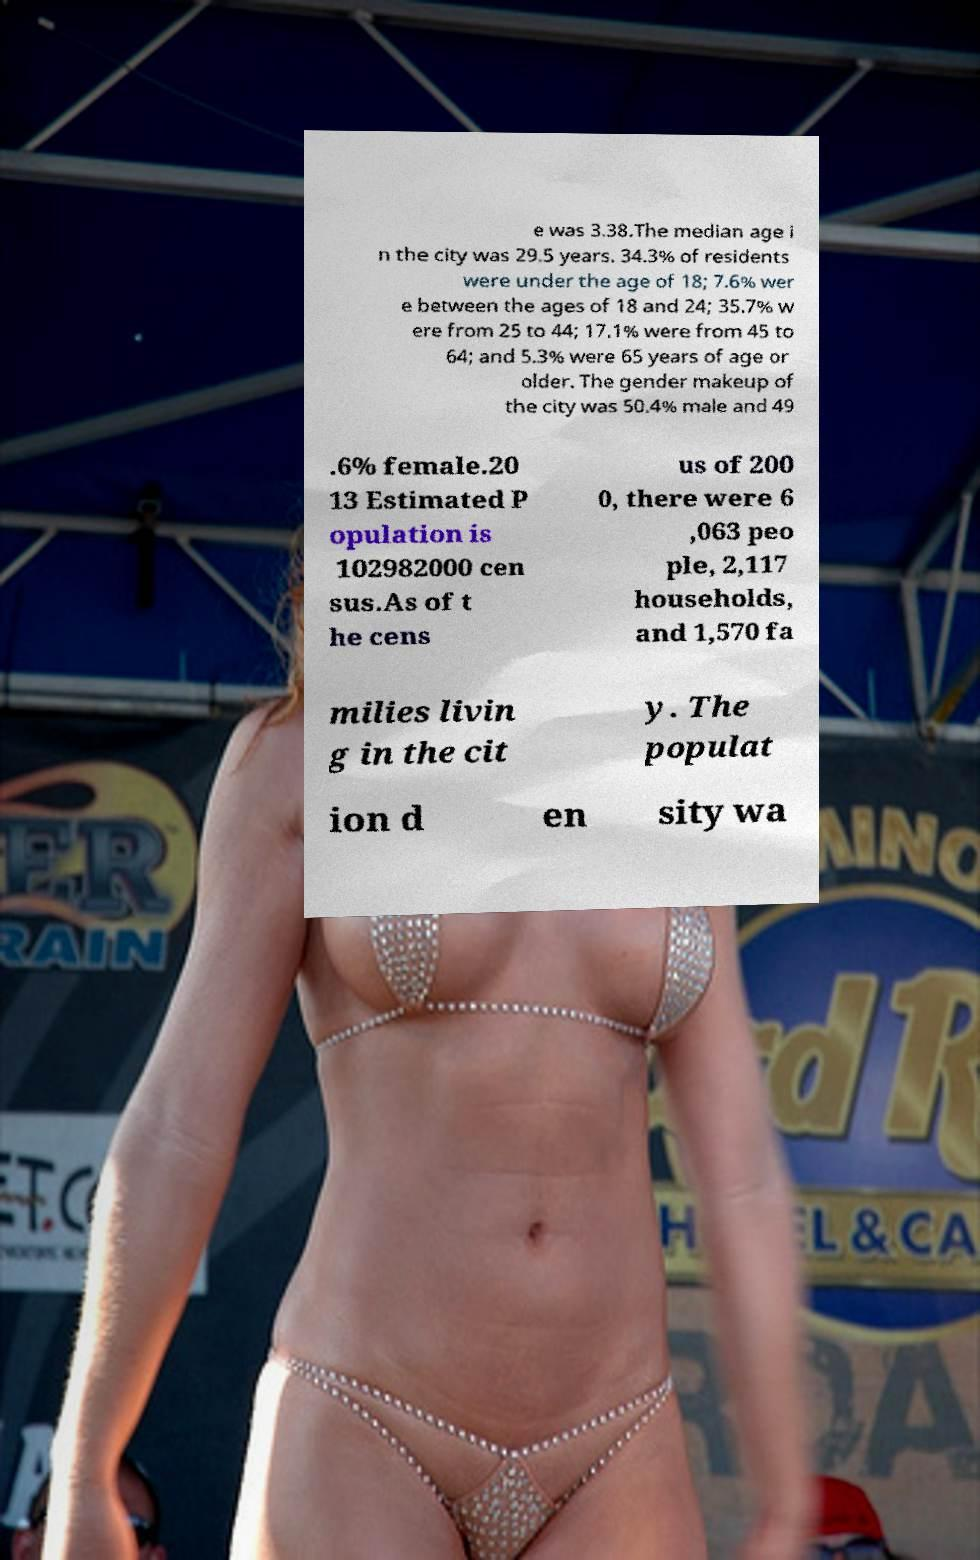What messages or text are displayed in this image? I need them in a readable, typed format. e was 3.38.The median age i n the city was 29.5 years. 34.3% of residents were under the age of 18; 7.6% wer e between the ages of 18 and 24; 35.7% w ere from 25 to 44; 17.1% were from 45 to 64; and 5.3% were 65 years of age or older. The gender makeup of the city was 50.4% male and 49 .6% female.20 13 Estimated P opulation is 102982000 cen sus.As of t he cens us of 200 0, there were 6 ,063 peo ple, 2,117 households, and 1,570 fa milies livin g in the cit y. The populat ion d en sity wa 